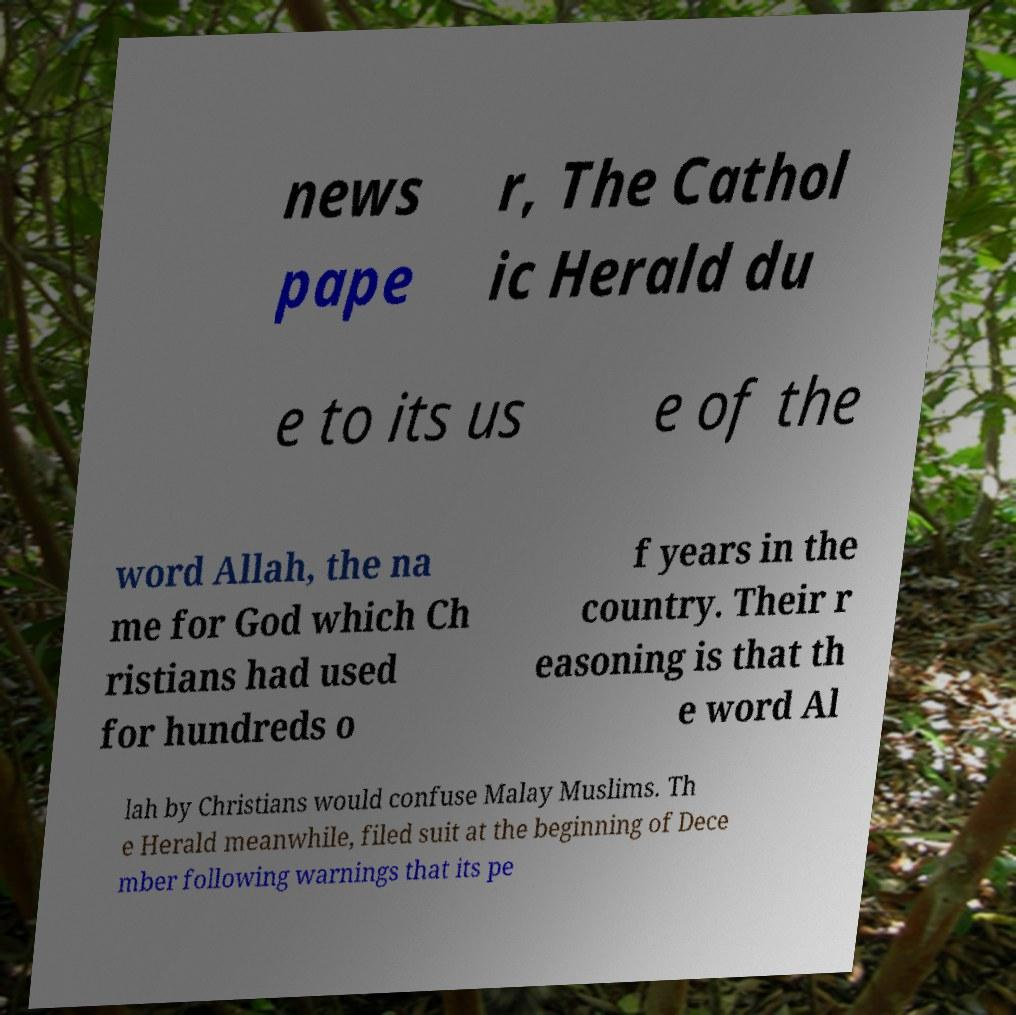Can you read and provide the text displayed in the image?This photo seems to have some interesting text. Can you extract and type it out for me? news pape r, The Cathol ic Herald du e to its us e of the word Allah, the na me for God which Ch ristians had used for hundreds o f years in the country. Their r easoning is that th e word Al lah by Christians would confuse Malay Muslims. Th e Herald meanwhile, filed suit at the beginning of Dece mber following warnings that its pe 